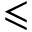Convert formula to latex. <formula><loc_0><loc_0><loc_500><loc_500>\leqslant</formula> 